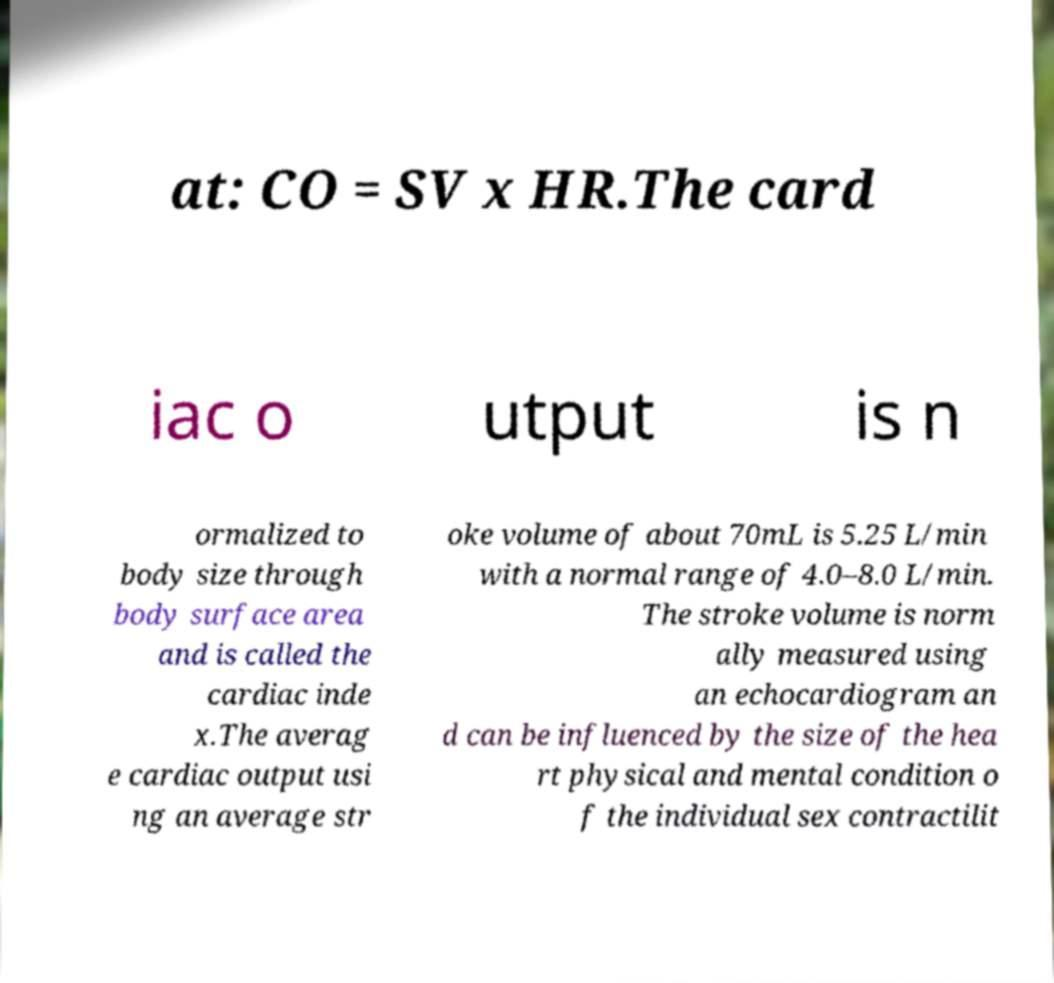Please read and relay the text visible in this image. What does it say? at: CO = SV x HR.The card iac o utput is n ormalized to body size through body surface area and is called the cardiac inde x.The averag e cardiac output usi ng an average str oke volume of about 70mL is 5.25 L/min with a normal range of 4.0–8.0 L/min. The stroke volume is norm ally measured using an echocardiogram an d can be influenced by the size of the hea rt physical and mental condition o f the individual sex contractilit 